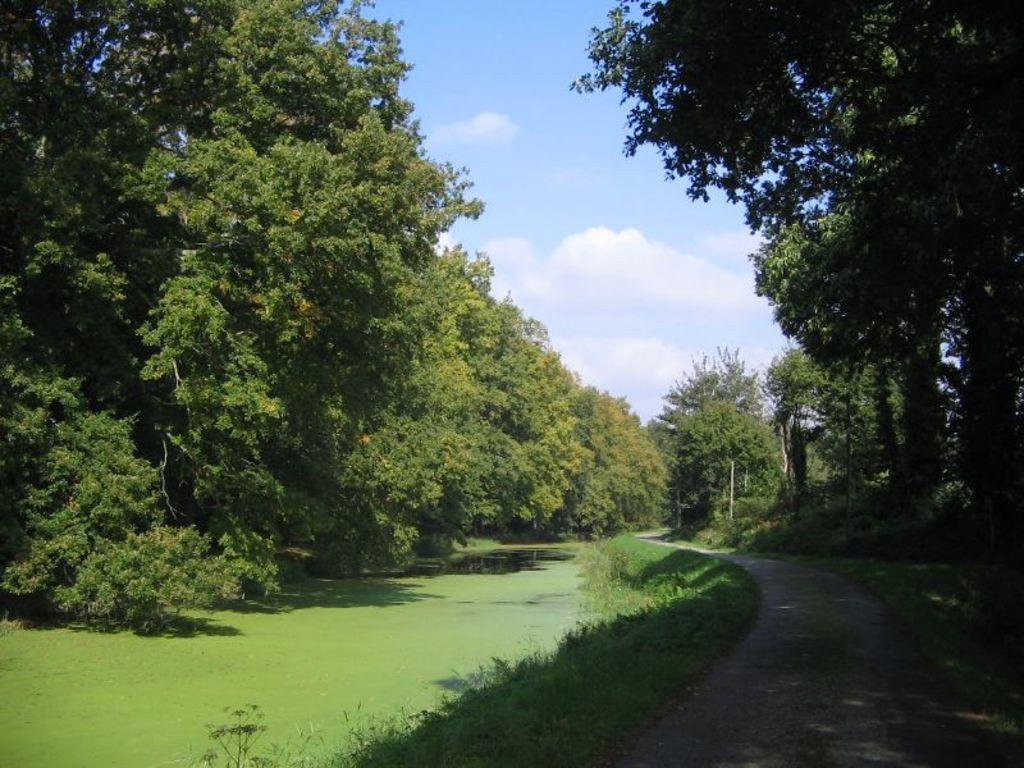What type of body of water is present in the image? There is a pond in the image. What natural elements can be seen in the image? There are many trees and plants in the image. Is there any man-made infrastructure visible in the image? Yes, there is a road in the image. How would you describe the sky in the image? The sky is blue and cloudy in the image. What type of beam can be seen supporting the mine in the image? There is no beam or mine present in the image. How many masses of rock are visible in the image? There are no masses of rock visible in the image; it features a pond, trees, plants, a road, and a blue and cloudy sky. 